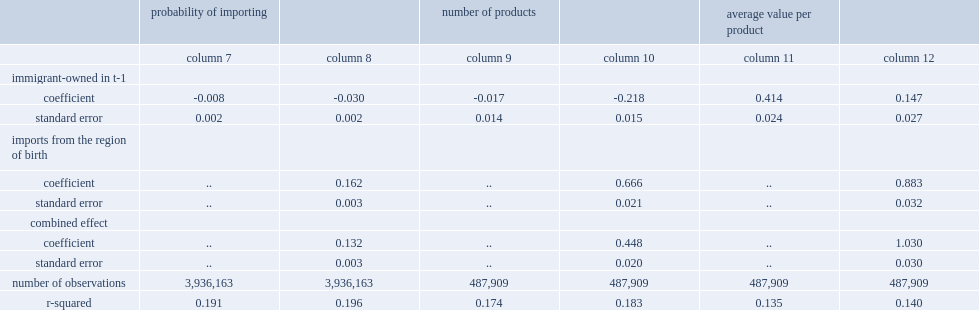How many percentage points are immigrant-owned wholesalers less likely on average to import compared with canadian-owned wholesalers? 0.008. How many percentage points are immigrant-owned wholesalers less likely to import from other regions? 0.03. 